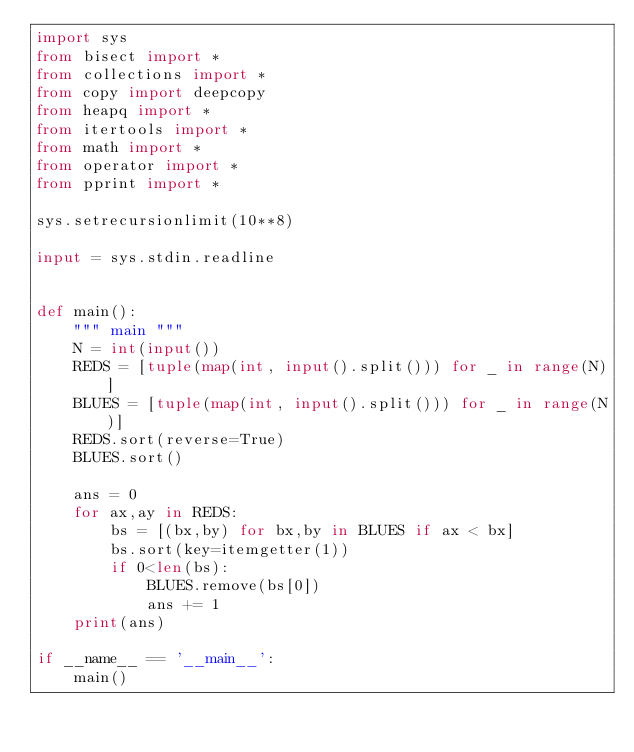<code> <loc_0><loc_0><loc_500><loc_500><_Python_>import sys
from bisect import *
from collections import *
from copy import deepcopy
from heapq import *
from itertools import *
from math import *
from operator import *
from pprint import *

sys.setrecursionlimit(10**8)

input = sys.stdin.readline


def main():
    """ main """
    N = int(input())
    REDS = [tuple(map(int, input().split())) for _ in range(N)]
    BLUES = [tuple(map(int, input().split())) for _ in range(N)]
    REDS.sort(reverse=True)
    BLUES.sort()

    ans = 0
    for ax,ay in REDS:
        bs = [(bx,by) for bx,by in BLUES if ax < bx]
        bs.sort(key=itemgetter(1))
        if 0<len(bs):
            BLUES.remove(bs[0])
            ans += 1
    print(ans)

if __name__ == '__main__':
    main()</code> 